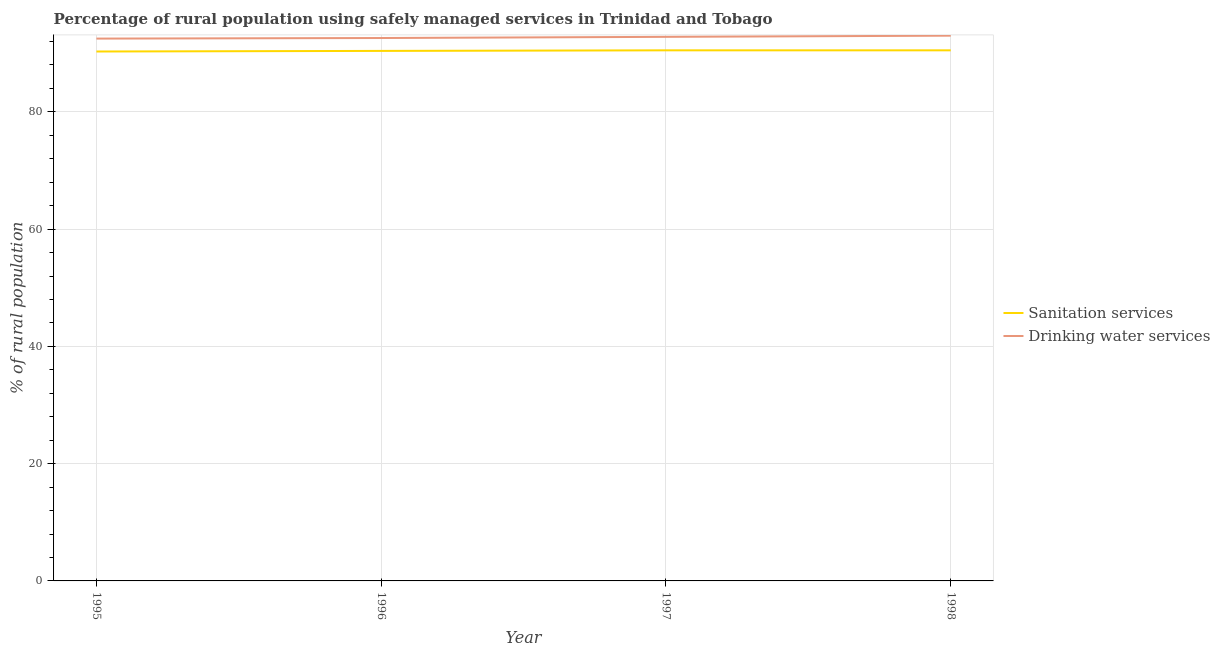Is the number of lines equal to the number of legend labels?
Offer a terse response. Yes. What is the percentage of rural population who used drinking water services in 1997?
Make the answer very short. 92.8. Across all years, what is the maximum percentage of rural population who used sanitation services?
Provide a succinct answer. 90.5. Across all years, what is the minimum percentage of rural population who used drinking water services?
Keep it short and to the point. 92.5. In which year was the percentage of rural population who used drinking water services minimum?
Your answer should be very brief. 1995. What is the total percentage of rural population who used drinking water services in the graph?
Offer a terse response. 370.9. What is the difference between the percentage of rural population who used drinking water services in 1995 and that in 1996?
Keep it short and to the point. -0.1. What is the difference between the percentage of rural population who used drinking water services in 1998 and the percentage of rural population who used sanitation services in 1995?
Your answer should be compact. 2.7. What is the average percentage of rural population who used sanitation services per year?
Offer a very short reply. 90.42. In how many years, is the percentage of rural population who used drinking water services greater than 20 %?
Keep it short and to the point. 4. What is the ratio of the percentage of rural population who used drinking water services in 1995 to that in 1996?
Ensure brevity in your answer.  1. Is the difference between the percentage of rural population who used sanitation services in 1995 and 1997 greater than the difference between the percentage of rural population who used drinking water services in 1995 and 1997?
Keep it short and to the point. Yes. What is the difference between the highest and the second highest percentage of rural population who used sanitation services?
Make the answer very short. 0. What is the difference between the highest and the lowest percentage of rural population who used drinking water services?
Your answer should be very brief. 0.5. Is the sum of the percentage of rural population who used drinking water services in 1997 and 1998 greater than the maximum percentage of rural population who used sanitation services across all years?
Your response must be concise. Yes. Are the values on the major ticks of Y-axis written in scientific E-notation?
Offer a very short reply. No. Does the graph contain any zero values?
Offer a terse response. No. Where does the legend appear in the graph?
Provide a succinct answer. Center right. What is the title of the graph?
Offer a terse response. Percentage of rural population using safely managed services in Trinidad and Tobago. Does "Travel services" appear as one of the legend labels in the graph?
Keep it short and to the point. No. What is the label or title of the X-axis?
Your answer should be very brief. Year. What is the label or title of the Y-axis?
Provide a succinct answer. % of rural population. What is the % of rural population of Sanitation services in 1995?
Keep it short and to the point. 90.3. What is the % of rural population of Drinking water services in 1995?
Give a very brief answer. 92.5. What is the % of rural population of Sanitation services in 1996?
Your response must be concise. 90.4. What is the % of rural population in Drinking water services in 1996?
Provide a succinct answer. 92.6. What is the % of rural population of Sanitation services in 1997?
Ensure brevity in your answer.  90.5. What is the % of rural population in Drinking water services in 1997?
Ensure brevity in your answer.  92.8. What is the % of rural population of Sanitation services in 1998?
Give a very brief answer. 90.5. What is the % of rural population of Drinking water services in 1998?
Your answer should be very brief. 93. Across all years, what is the maximum % of rural population of Sanitation services?
Offer a very short reply. 90.5. Across all years, what is the maximum % of rural population of Drinking water services?
Provide a succinct answer. 93. Across all years, what is the minimum % of rural population in Sanitation services?
Provide a succinct answer. 90.3. Across all years, what is the minimum % of rural population of Drinking water services?
Offer a terse response. 92.5. What is the total % of rural population in Sanitation services in the graph?
Offer a terse response. 361.7. What is the total % of rural population in Drinking water services in the graph?
Give a very brief answer. 370.9. What is the difference between the % of rural population in Sanitation services in 1995 and that in 1996?
Offer a terse response. -0.1. What is the difference between the % of rural population in Drinking water services in 1995 and that in 1997?
Your response must be concise. -0.3. What is the difference between the % of rural population in Drinking water services in 1995 and that in 1998?
Offer a very short reply. -0.5. What is the difference between the % of rural population in Drinking water services in 1996 and that in 1998?
Keep it short and to the point. -0.4. What is the difference between the % of rural population in Drinking water services in 1997 and that in 1998?
Ensure brevity in your answer.  -0.2. What is the difference between the % of rural population in Sanitation services in 1995 and the % of rural population in Drinking water services in 1996?
Ensure brevity in your answer.  -2.3. What is the difference between the % of rural population of Sanitation services in 1996 and the % of rural population of Drinking water services in 1997?
Offer a very short reply. -2.4. What is the difference between the % of rural population of Sanitation services in 1996 and the % of rural population of Drinking water services in 1998?
Provide a short and direct response. -2.6. What is the average % of rural population in Sanitation services per year?
Give a very brief answer. 90.42. What is the average % of rural population in Drinking water services per year?
Keep it short and to the point. 92.72. In the year 1998, what is the difference between the % of rural population in Sanitation services and % of rural population in Drinking water services?
Your answer should be compact. -2.5. What is the ratio of the % of rural population of Drinking water services in 1995 to that in 1996?
Your response must be concise. 1. What is the ratio of the % of rural population of Sanitation services in 1995 to that in 1997?
Your answer should be very brief. 1. What is the ratio of the % of rural population of Sanitation services in 1995 to that in 1998?
Your answer should be very brief. 1. What is the ratio of the % of rural population of Drinking water services in 1996 to that in 1997?
Make the answer very short. 1. What is the ratio of the % of rural population of Sanitation services in 1996 to that in 1998?
Give a very brief answer. 1. What is the ratio of the % of rural population of Drinking water services in 1996 to that in 1998?
Your answer should be compact. 1. What is the ratio of the % of rural population in Drinking water services in 1997 to that in 1998?
Provide a short and direct response. 1. What is the difference between the highest and the second highest % of rural population of Sanitation services?
Provide a short and direct response. 0. What is the difference between the highest and the lowest % of rural population in Sanitation services?
Your response must be concise. 0.2. 